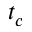<formula> <loc_0><loc_0><loc_500><loc_500>t _ { c }</formula> 